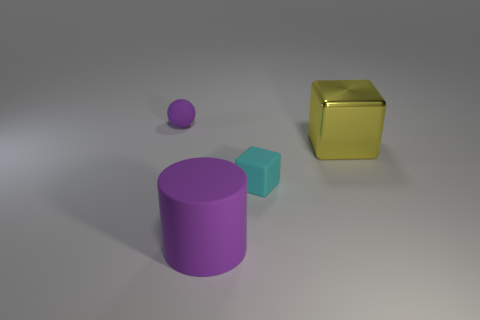Add 1 small cyan blocks. How many objects exist? 5 Subtract all cyan blocks. How many blocks are left? 1 Subtract all cylinders. How many objects are left? 3 Subtract 1 blocks. How many blocks are left? 1 Add 4 metallic things. How many metallic things are left? 5 Add 4 large purple things. How many large purple things exist? 5 Subtract 0 gray cylinders. How many objects are left? 4 Subtract all purple cubes. Subtract all green cylinders. How many cubes are left? 2 Subtract all yellow metal objects. Subtract all big metallic blocks. How many objects are left? 2 